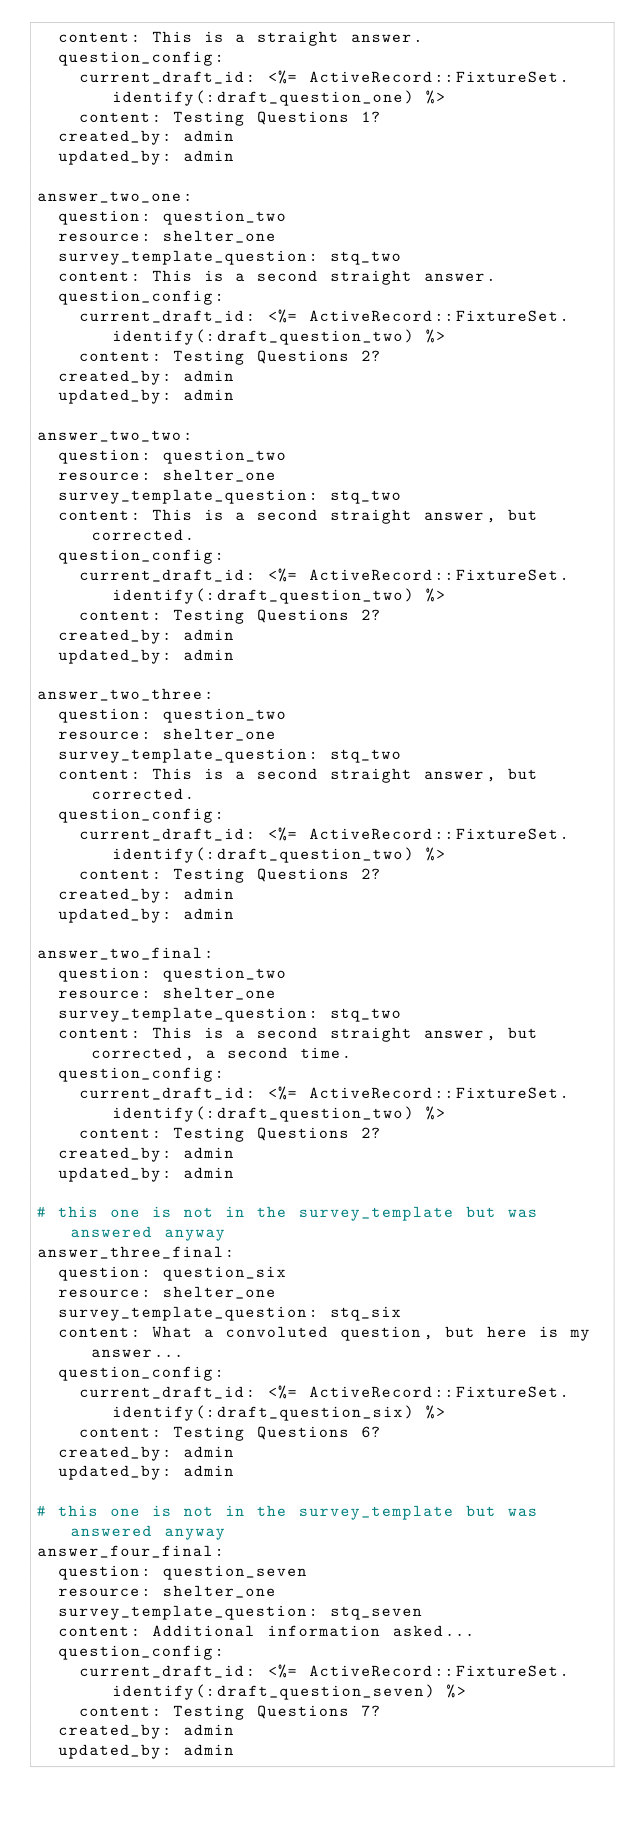<code> <loc_0><loc_0><loc_500><loc_500><_YAML_>  content: This is a straight answer.
  question_config:
    current_draft_id: <%= ActiveRecord::FixtureSet.identify(:draft_question_one) %>
    content: Testing Questions 1?
  created_by: admin
  updated_by: admin

answer_two_one:
  question: question_two
  resource: shelter_one
  survey_template_question: stq_two
  content: This is a second straight answer.
  question_config:
    current_draft_id: <%= ActiveRecord::FixtureSet.identify(:draft_question_two) %>
    content: Testing Questions 2?
  created_by: admin
  updated_by: admin

answer_two_two:
  question: question_two
  resource: shelter_one
  survey_template_question: stq_two
  content: This is a second straight answer, but corrected.
  question_config:
    current_draft_id: <%= ActiveRecord::FixtureSet.identify(:draft_question_two) %>
    content: Testing Questions 2?
  created_by: admin
  updated_by: admin

answer_two_three:
  question: question_two
  resource: shelter_one
  survey_template_question: stq_two
  content: This is a second straight answer, but corrected.
  question_config:
    current_draft_id: <%= ActiveRecord::FixtureSet.identify(:draft_question_two) %>
    content: Testing Questions 2?
  created_by: admin
  updated_by: admin

answer_two_final:
  question: question_two
  resource: shelter_one
  survey_template_question: stq_two
  content: This is a second straight answer, but corrected, a second time.
  question_config:
    current_draft_id: <%= ActiveRecord::FixtureSet.identify(:draft_question_two) %>
    content: Testing Questions 2?
  created_by: admin
  updated_by: admin

# this one is not in the survey_template but was answered anyway
answer_three_final:
  question: question_six
  resource: shelter_one
  survey_template_question: stq_six
  content: What a convoluted question, but here is my answer...
  question_config:
    current_draft_id: <%= ActiveRecord::FixtureSet.identify(:draft_question_six) %>
    content: Testing Questions 6?
  created_by: admin
  updated_by: admin

# this one is not in the survey_template but was answered anyway
answer_four_final:
  question: question_seven
  resource: shelter_one
  survey_template_question: stq_seven
  content: Additional information asked...
  question_config:
    current_draft_id: <%= ActiveRecord::FixtureSet.identify(:draft_question_seven) %>
    content: Testing Questions 7?
  created_by: admin
  updated_by: admin
</code> 